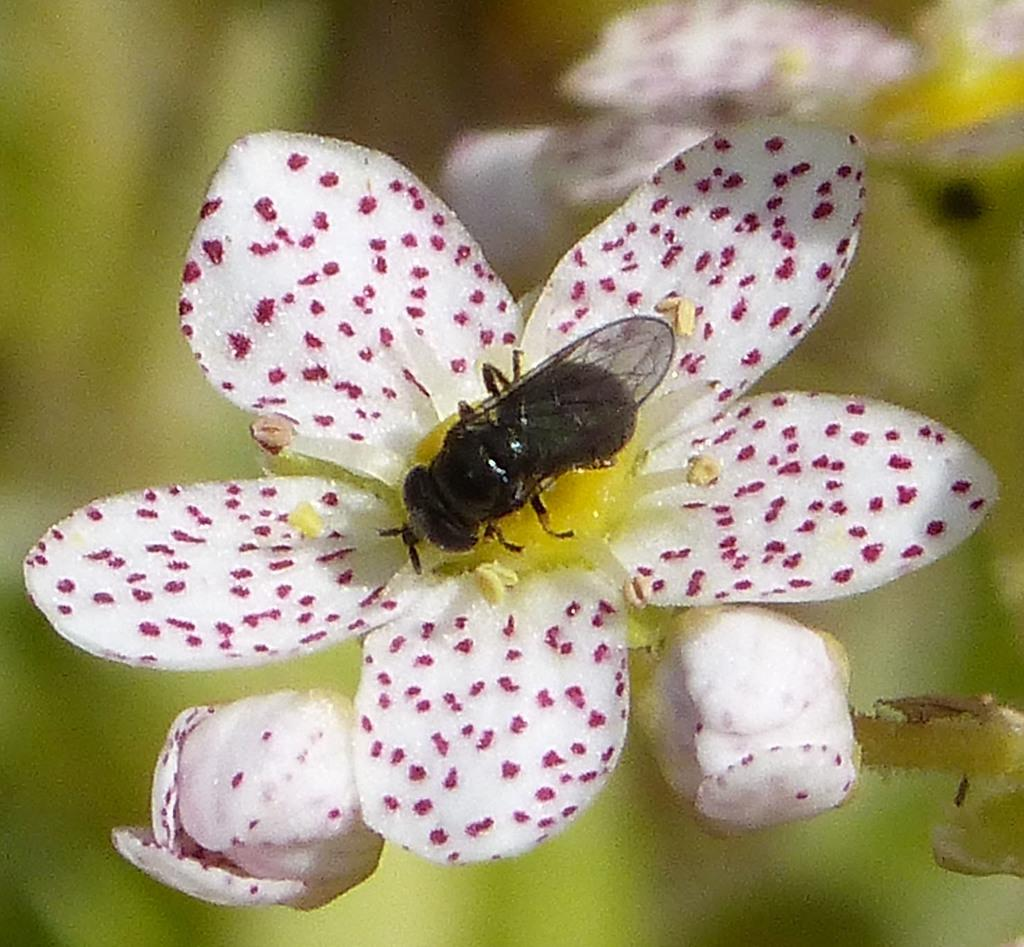What is present in the image that represents a natural element? There are flowers in the image. Can you describe the interaction between the bee and the flowers? A bee is sitting on a flower in the image. What can be seen in the background of the image? There are flowering plants in the background of the image. What time of day might the image have been taken? The image was likely taken during the day, as flowers are typically more visible and vibrant in daylight. What type of cake can be seen in the image? There is no cake present in the image; it features flowers and a bee. How many kites are visible in the image? There are no kites present in the image. 